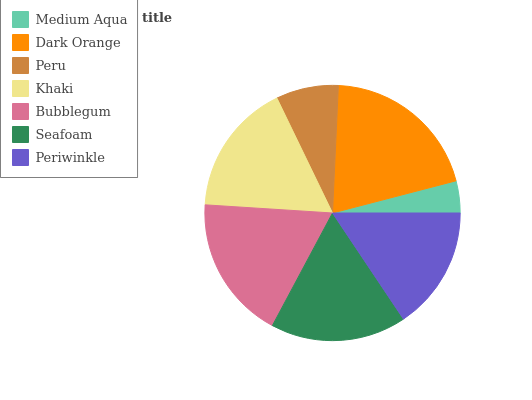Is Medium Aqua the minimum?
Answer yes or no. Yes. Is Dark Orange the maximum?
Answer yes or no. Yes. Is Peru the minimum?
Answer yes or no. No. Is Peru the maximum?
Answer yes or no. No. Is Dark Orange greater than Peru?
Answer yes or no. Yes. Is Peru less than Dark Orange?
Answer yes or no. Yes. Is Peru greater than Dark Orange?
Answer yes or no. No. Is Dark Orange less than Peru?
Answer yes or no. No. Is Khaki the high median?
Answer yes or no. Yes. Is Khaki the low median?
Answer yes or no. Yes. Is Periwinkle the high median?
Answer yes or no. No. Is Peru the low median?
Answer yes or no. No. 